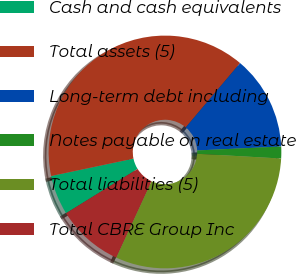Convert chart to OTSL. <chart><loc_0><loc_0><loc_500><loc_500><pie_chart><fcel>Cash and cash equivalents<fcel>Total assets (5)<fcel>Long-term debt including<fcel>Notes payable on real estate<fcel>Total liabilities (5)<fcel>Total CBRE Group Inc<nl><fcel>5.51%<fcel>39.49%<fcel>13.08%<fcel>1.65%<fcel>30.99%<fcel>9.29%<nl></chart> 